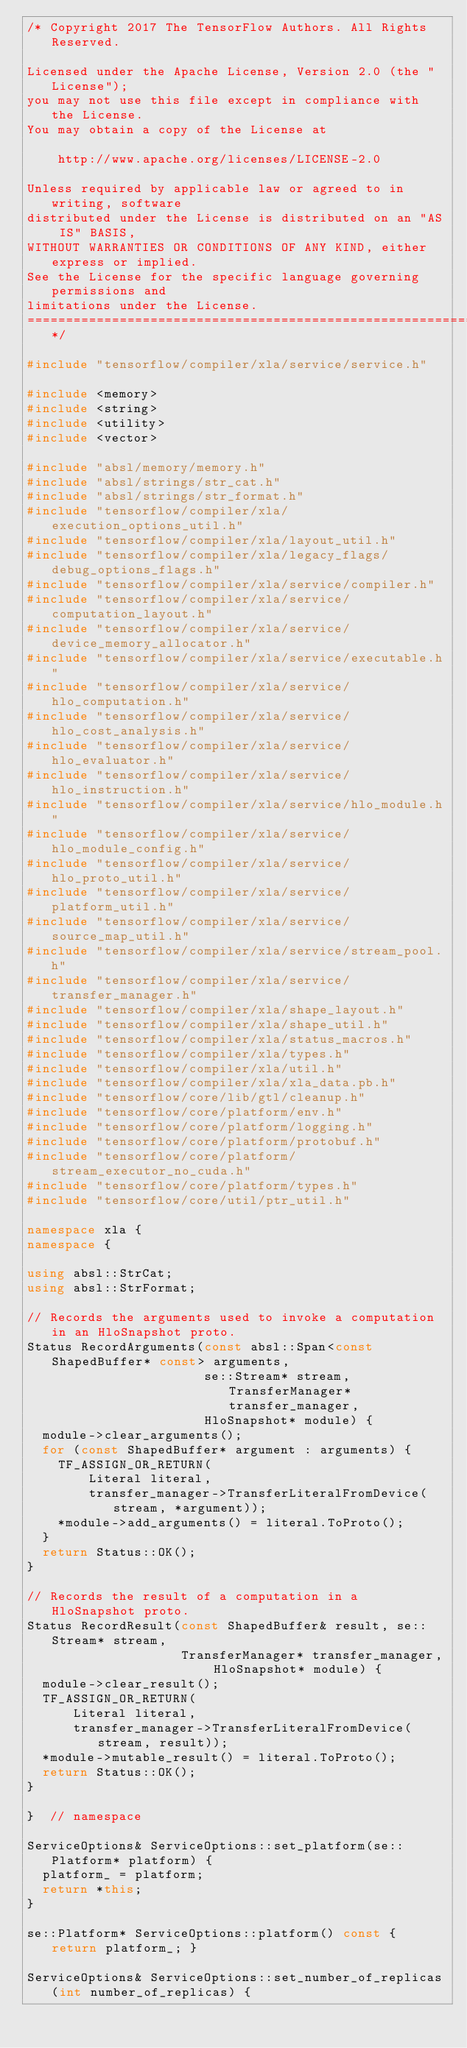<code> <loc_0><loc_0><loc_500><loc_500><_C++_>/* Copyright 2017 The TensorFlow Authors. All Rights Reserved.

Licensed under the Apache License, Version 2.0 (the "License");
you may not use this file except in compliance with the License.
You may obtain a copy of the License at

    http://www.apache.org/licenses/LICENSE-2.0

Unless required by applicable law or agreed to in writing, software
distributed under the License is distributed on an "AS IS" BASIS,
WITHOUT WARRANTIES OR CONDITIONS OF ANY KIND, either express or implied.
See the License for the specific language governing permissions and
limitations under the License.
==============================================================================*/

#include "tensorflow/compiler/xla/service/service.h"

#include <memory>
#include <string>
#include <utility>
#include <vector>

#include "absl/memory/memory.h"
#include "absl/strings/str_cat.h"
#include "absl/strings/str_format.h"
#include "tensorflow/compiler/xla/execution_options_util.h"
#include "tensorflow/compiler/xla/layout_util.h"
#include "tensorflow/compiler/xla/legacy_flags/debug_options_flags.h"
#include "tensorflow/compiler/xla/service/compiler.h"
#include "tensorflow/compiler/xla/service/computation_layout.h"
#include "tensorflow/compiler/xla/service/device_memory_allocator.h"
#include "tensorflow/compiler/xla/service/executable.h"
#include "tensorflow/compiler/xla/service/hlo_computation.h"
#include "tensorflow/compiler/xla/service/hlo_cost_analysis.h"
#include "tensorflow/compiler/xla/service/hlo_evaluator.h"
#include "tensorflow/compiler/xla/service/hlo_instruction.h"
#include "tensorflow/compiler/xla/service/hlo_module.h"
#include "tensorflow/compiler/xla/service/hlo_module_config.h"
#include "tensorflow/compiler/xla/service/hlo_proto_util.h"
#include "tensorflow/compiler/xla/service/platform_util.h"
#include "tensorflow/compiler/xla/service/source_map_util.h"
#include "tensorflow/compiler/xla/service/stream_pool.h"
#include "tensorflow/compiler/xla/service/transfer_manager.h"
#include "tensorflow/compiler/xla/shape_layout.h"
#include "tensorflow/compiler/xla/shape_util.h"
#include "tensorflow/compiler/xla/status_macros.h"
#include "tensorflow/compiler/xla/types.h"
#include "tensorflow/compiler/xla/util.h"
#include "tensorflow/compiler/xla/xla_data.pb.h"
#include "tensorflow/core/lib/gtl/cleanup.h"
#include "tensorflow/core/platform/env.h"
#include "tensorflow/core/platform/logging.h"
#include "tensorflow/core/platform/protobuf.h"
#include "tensorflow/core/platform/stream_executor_no_cuda.h"
#include "tensorflow/core/platform/types.h"
#include "tensorflow/core/util/ptr_util.h"

namespace xla {
namespace {

using absl::StrCat;
using absl::StrFormat;

// Records the arguments used to invoke a computation in an HloSnapshot proto.
Status RecordArguments(const absl::Span<const ShapedBuffer* const> arguments,
                       se::Stream* stream, TransferManager* transfer_manager,
                       HloSnapshot* module) {
  module->clear_arguments();
  for (const ShapedBuffer* argument : arguments) {
    TF_ASSIGN_OR_RETURN(
        Literal literal,
        transfer_manager->TransferLiteralFromDevice(stream, *argument));
    *module->add_arguments() = literal.ToProto();
  }
  return Status::OK();
}

// Records the result of a computation in a HloSnapshot proto.
Status RecordResult(const ShapedBuffer& result, se::Stream* stream,
                    TransferManager* transfer_manager, HloSnapshot* module) {
  module->clear_result();
  TF_ASSIGN_OR_RETURN(
      Literal literal,
      transfer_manager->TransferLiteralFromDevice(stream, result));
  *module->mutable_result() = literal.ToProto();
  return Status::OK();
}

}  // namespace

ServiceOptions& ServiceOptions::set_platform(se::Platform* platform) {
  platform_ = platform;
  return *this;
}

se::Platform* ServiceOptions::platform() const { return platform_; }

ServiceOptions& ServiceOptions::set_number_of_replicas(int number_of_replicas) {</code> 